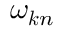Convert formula to latex. <formula><loc_0><loc_0><loc_500><loc_500>\omega _ { k n }</formula> 